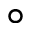Convert formula to latex. <formula><loc_0><loc_0><loc_500><loc_500>\circ</formula> 